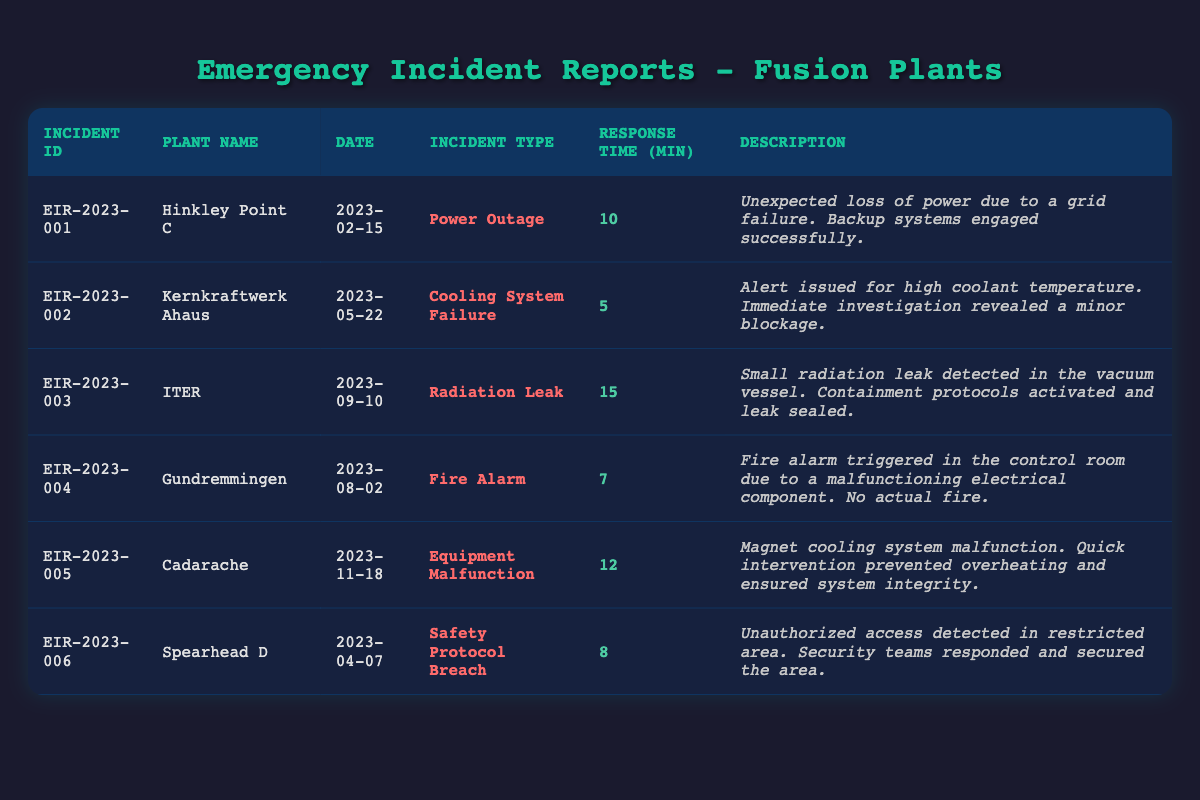What incident at Hinkley Point C occurred on February 15, 2023? Referring to the table, the incident ID EIR-2023-001 for Hinkley Point C on February 15, 2023, is categorized as a "Power Outage".
Answer: Power Outage What was the response time for the cooling system failure at Kernkraftwerk Ahaus? The table indicates that the response time for the incident at Kernkraftwerk Ahaus, categorized as a "Cooling System Failure", is 5 minutes.
Answer: 5 minutes True or False: The response time for the radiation leak at ITER was shorter than the response time for the equipment malfunction at Cadarache. The response time for the radiation leak at ITER is 15 minutes, while the response time for the equipment malfunction at Cadarache is 12 minutes. Since 15 > 12, the statement is false.
Answer: False What was the average response time of all incidents listed in the table? The response times are 10, 5, 15, 7, 12, and 8 minutes. Summing these gives: 10 + 5 + 15 + 7 + 12 + 8 = 57 minutes. There are 6 incidents, so the average response time is 57/6 = 9.5 minutes.
Answer: 9.5 minutes Which incident had the longest response time? By examining the response times, the incident at ITER, with a response time of 15 minutes, is the longest among all incidents in the table.
Answer: ITER (Radiation Leak) What was the total response time of all incidents involving equipment issues (Power Outage, Cooling System Failure, and Equipment Malfunction)? The response times for these incidents are: Power Outage (10 minutes), Cooling System Failure (5 minutes), and Equipment Malfunction (12 minutes). Summing them gives: 10 + 5 + 12 = 27 minutes.
Answer: 27 minutes Was there any event at Gundremmingen where an actual fire occurred? According to the description for the incident at Gundremmingen, the fire alarm was triggered due to a malfunction, but there was no actual fire reported.
Answer: No Which plant had the quickest response time for an incident? The table shows that the quickest response time is for the Cooling System Failure at Kernkraftwerk Ahaus, which was recorded at 5 minutes.
Answer: Kernkraftwerk Ahaus How many incidents were reported in April 2023? The table shows there were two incidents reported in April 2023: one at Spearhead D on April 7 and one at Kernkraftwerk Ahaus on May 22, thus one incident was in April.
Answer: 1 incident Which month experienced the most incidents according to the table? By reviewing the dates, there was one incident in February, one in May, one in August, one in September, and one in April. August has the most, with two incidents, thus the month with the most incidents is April.
Answer: August (2 incidents) 